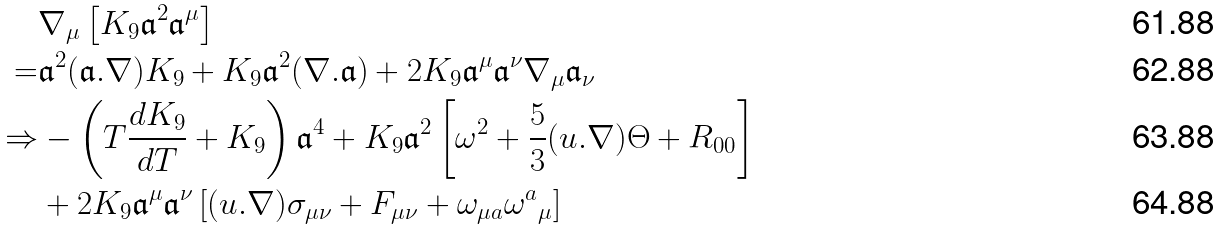<formula> <loc_0><loc_0><loc_500><loc_500>& \nabla _ { \mu } \left [ K _ { 9 } { \mathfrak a } ^ { 2 } { \mathfrak a } ^ { \mu } \right ] \\ = & { \mathfrak a } ^ { 2 } ( { \mathfrak a } . \nabla ) K _ { 9 } + K _ { 9 } { \mathfrak a } ^ { 2 } ( \nabla . { \mathfrak a } ) + 2 K _ { 9 } { \mathfrak a } ^ { \mu } { \mathfrak a } ^ { \nu } \nabla _ { \mu } { \mathfrak a } _ { \nu } \\ \Rightarrow & - \left ( T \frac { d K _ { 9 } } { d T } + K _ { 9 } \right ) { \mathfrak a } ^ { 4 } + K _ { 9 } { \mathfrak a } ^ { 2 } \left [ \omega ^ { 2 } + \frac { 5 } { 3 } ( u . \nabla ) \Theta + R _ { 0 0 } \right ] \\ & + 2 K _ { 9 } { \mathfrak a } ^ { \mu } { \mathfrak a } ^ { \nu } \left [ ( u . \nabla ) \sigma _ { \mu \nu } + F _ { \mu \nu } + \omega _ { \mu a } { \omega ^ { a } } _ { \mu } \right ]</formula> 